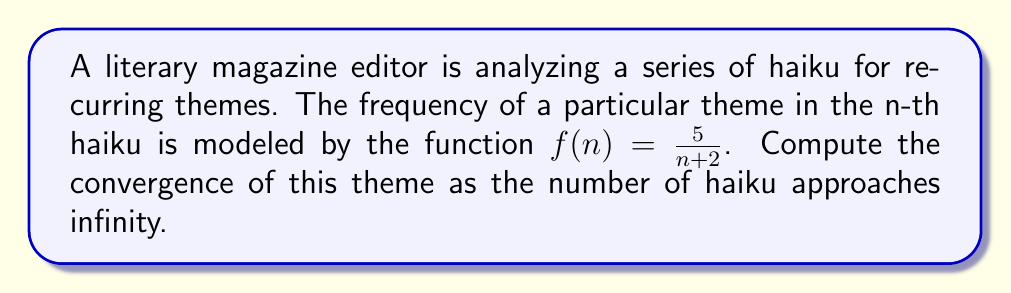Teach me how to tackle this problem. To determine the convergence of the recurring theme, we need to evaluate the limit of the function $f(n)$ as $n$ approaches infinity. Let's approach this step-by-step:

1) We start with the given function:

   $f(n) = \frac{5}{n+2}$

2) To find the limit as $n$ approaches infinity, we evaluate:

   $\lim_{n \to \infty} f(n) = \lim_{n \to \infty} \frac{5}{n+2}$

3) As $n$ approaches infinity, the denominator $(n+2)$ grows infinitely large, while the numerator remains constant at 5.

4) When a constant is divided by an infinitely large number, the result approaches zero:

   $\lim_{n \to \infty} \frac{5}{n+2} = 0$

5) This means that as the number of haiku increases indefinitely, the frequency of the theme approaches zero.

6) In calculus terms, we say that the series converges to 0.

This result suggests that while the theme may be prominent in earlier haiku, its occurrence becomes increasingly rare in later poems, eventually becoming negligible as the collection grows very large.
Answer: The recurring theme converges to 0 as the number of haiku approaches infinity. 